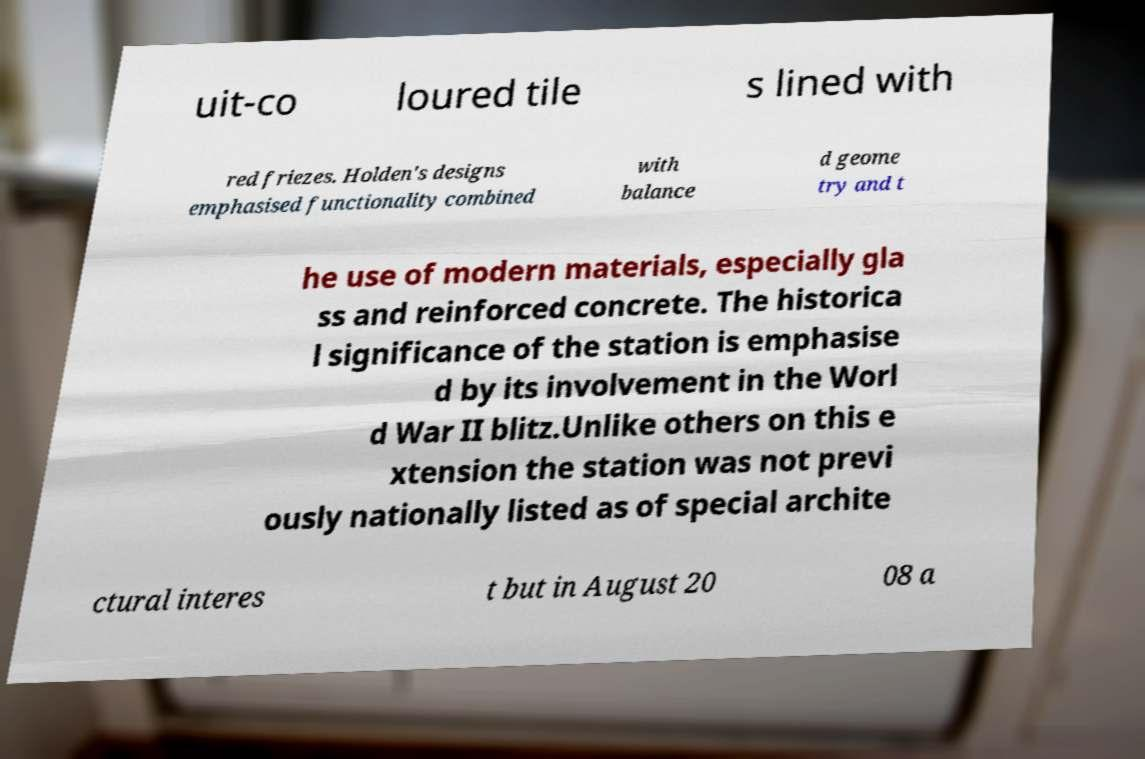For documentation purposes, I need the text within this image transcribed. Could you provide that? uit-co loured tile s lined with red friezes. Holden's designs emphasised functionality combined with balance d geome try and t he use of modern materials, especially gla ss and reinforced concrete. The historica l significance of the station is emphasise d by its involvement in the Worl d War II blitz.Unlike others on this e xtension the station was not previ ously nationally listed as of special archite ctural interes t but in August 20 08 a 